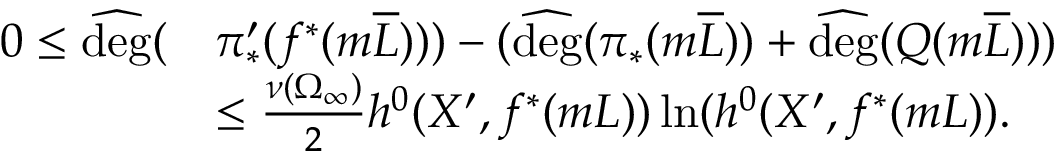<formula> <loc_0><loc_0><loc_500><loc_500>\begin{array} { r l } { 0 \leq \widehat { d e g } ( } & { \pi _ { * } ^ { \prime } ( f ^ { * } ( m \overline { L } ) ) ) - ( \widehat { d e g } ( \pi _ { * } ( m \overline { L } ) ) + \widehat { d e g } ( Q ( m \overline { L } ) ) ) } \\ & { \leq \frac { \nu ( \Omega _ { \infty } ) } { 2 } h ^ { 0 } ( X ^ { \prime } , f ^ { * } ( m L ) ) \ln ( h ^ { 0 } ( X ^ { \prime } , f ^ { * } ( m L ) ) . } \end{array}</formula> 